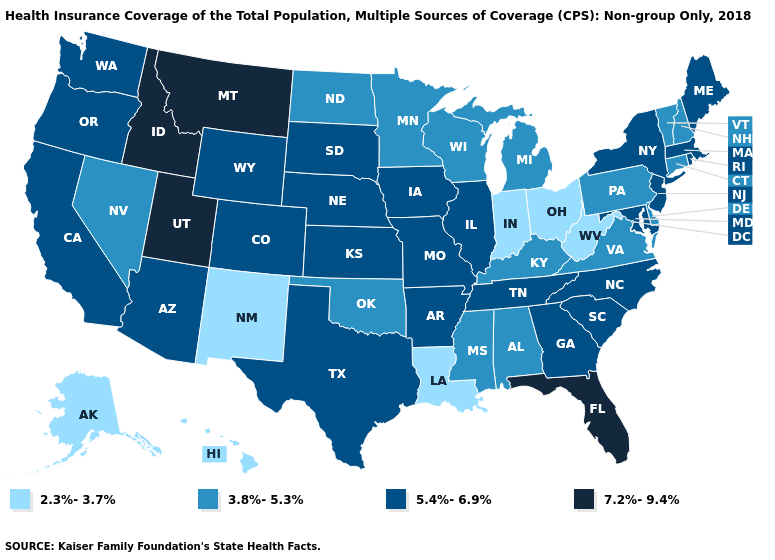Name the states that have a value in the range 3.8%-5.3%?
Quick response, please. Alabama, Connecticut, Delaware, Kentucky, Michigan, Minnesota, Mississippi, Nevada, New Hampshire, North Dakota, Oklahoma, Pennsylvania, Vermont, Virginia, Wisconsin. Does the first symbol in the legend represent the smallest category?
Concise answer only. Yes. What is the value of Massachusetts?
Answer briefly. 5.4%-6.9%. Does Louisiana have the lowest value in the South?
Answer briefly. Yes. Does Arkansas have the highest value in the South?
Answer briefly. No. Does Georgia have a lower value than Iowa?
Write a very short answer. No. Does Michigan have the same value as Maine?
Short answer required. No. Name the states that have a value in the range 7.2%-9.4%?
Be succinct. Florida, Idaho, Montana, Utah. Name the states that have a value in the range 2.3%-3.7%?
Answer briefly. Alaska, Hawaii, Indiana, Louisiana, New Mexico, Ohio, West Virginia. Among the states that border Pennsylvania , does Maryland have the lowest value?
Short answer required. No. Among the states that border Utah , does Idaho have the lowest value?
Be succinct. No. Does Delaware have the highest value in the USA?
Write a very short answer. No. Name the states that have a value in the range 3.8%-5.3%?
Answer briefly. Alabama, Connecticut, Delaware, Kentucky, Michigan, Minnesota, Mississippi, Nevada, New Hampshire, North Dakota, Oklahoma, Pennsylvania, Vermont, Virginia, Wisconsin. How many symbols are there in the legend?
Keep it brief. 4. What is the value of Maine?
Short answer required. 5.4%-6.9%. 